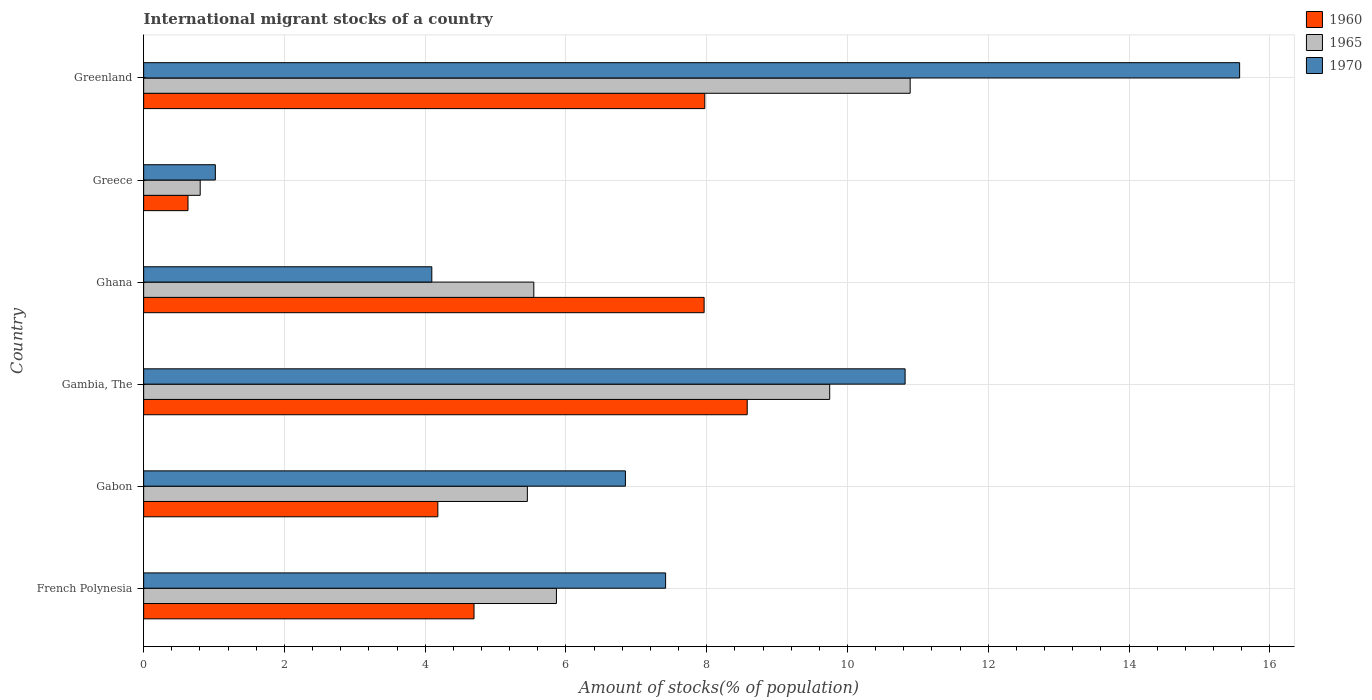How many groups of bars are there?
Make the answer very short. 6. Are the number of bars per tick equal to the number of legend labels?
Provide a succinct answer. Yes. Are the number of bars on each tick of the Y-axis equal?
Ensure brevity in your answer.  Yes. How many bars are there on the 2nd tick from the top?
Your answer should be compact. 3. How many bars are there on the 5th tick from the bottom?
Ensure brevity in your answer.  3. In how many cases, is the number of bars for a given country not equal to the number of legend labels?
Your answer should be very brief. 0. What is the amount of stocks in in 1965 in Greenland?
Offer a terse response. 10.89. Across all countries, what is the maximum amount of stocks in in 1960?
Keep it short and to the point. 8.58. Across all countries, what is the minimum amount of stocks in in 1965?
Your answer should be very brief. 0.8. In which country was the amount of stocks in in 1970 maximum?
Ensure brevity in your answer.  Greenland. In which country was the amount of stocks in in 1960 minimum?
Keep it short and to the point. Greece. What is the total amount of stocks in in 1970 in the graph?
Offer a terse response. 45.76. What is the difference between the amount of stocks in in 1960 in Gabon and that in Gambia, The?
Your response must be concise. -4.4. What is the difference between the amount of stocks in in 1970 in Ghana and the amount of stocks in in 1960 in Gabon?
Offer a very short reply. -0.09. What is the average amount of stocks in in 1960 per country?
Offer a very short reply. 5.67. What is the difference between the amount of stocks in in 1965 and amount of stocks in in 1960 in Greece?
Your answer should be compact. 0.17. In how many countries, is the amount of stocks in in 1960 greater than 2.8 %?
Your response must be concise. 5. What is the ratio of the amount of stocks in in 1965 in Gabon to that in Gambia, The?
Provide a short and direct response. 0.56. Is the amount of stocks in in 1960 in French Polynesia less than that in Ghana?
Offer a terse response. Yes. Is the difference between the amount of stocks in in 1965 in Gabon and Ghana greater than the difference between the amount of stocks in in 1960 in Gabon and Ghana?
Your response must be concise. Yes. What is the difference between the highest and the second highest amount of stocks in in 1970?
Your answer should be compact. 4.75. What is the difference between the highest and the lowest amount of stocks in in 1960?
Ensure brevity in your answer.  7.95. In how many countries, is the amount of stocks in in 1965 greater than the average amount of stocks in in 1965 taken over all countries?
Your answer should be very brief. 2. What does the 2nd bar from the top in French Polynesia represents?
Your answer should be compact. 1965. What does the 3rd bar from the bottom in Gambia, The represents?
Provide a short and direct response. 1970. Are all the bars in the graph horizontal?
Provide a succinct answer. Yes. Does the graph contain any zero values?
Your answer should be compact. No. Does the graph contain grids?
Offer a very short reply. Yes. How many legend labels are there?
Offer a terse response. 3. How are the legend labels stacked?
Your response must be concise. Vertical. What is the title of the graph?
Make the answer very short. International migrant stocks of a country. Does "1982" appear as one of the legend labels in the graph?
Your answer should be compact. No. What is the label or title of the X-axis?
Keep it short and to the point. Amount of stocks(% of population). What is the label or title of the Y-axis?
Make the answer very short. Country. What is the Amount of stocks(% of population) of 1960 in French Polynesia?
Offer a very short reply. 4.69. What is the Amount of stocks(% of population) in 1965 in French Polynesia?
Provide a succinct answer. 5.86. What is the Amount of stocks(% of population) in 1970 in French Polynesia?
Your answer should be very brief. 7.42. What is the Amount of stocks(% of population) of 1960 in Gabon?
Keep it short and to the point. 4.18. What is the Amount of stocks(% of population) in 1965 in Gabon?
Offer a very short reply. 5.45. What is the Amount of stocks(% of population) in 1970 in Gabon?
Keep it short and to the point. 6.84. What is the Amount of stocks(% of population) in 1960 in Gambia, The?
Your answer should be very brief. 8.58. What is the Amount of stocks(% of population) of 1965 in Gambia, The?
Provide a succinct answer. 9.75. What is the Amount of stocks(% of population) of 1970 in Gambia, The?
Offer a terse response. 10.82. What is the Amount of stocks(% of population) of 1960 in Ghana?
Provide a succinct answer. 7.96. What is the Amount of stocks(% of population) in 1965 in Ghana?
Keep it short and to the point. 5.54. What is the Amount of stocks(% of population) in 1970 in Ghana?
Give a very brief answer. 4.09. What is the Amount of stocks(% of population) of 1960 in Greece?
Provide a succinct answer. 0.63. What is the Amount of stocks(% of population) in 1965 in Greece?
Give a very brief answer. 0.8. What is the Amount of stocks(% of population) of 1970 in Greece?
Your response must be concise. 1.02. What is the Amount of stocks(% of population) of 1960 in Greenland?
Your answer should be very brief. 7.97. What is the Amount of stocks(% of population) in 1965 in Greenland?
Offer a terse response. 10.89. What is the Amount of stocks(% of population) in 1970 in Greenland?
Ensure brevity in your answer.  15.57. Across all countries, what is the maximum Amount of stocks(% of population) in 1960?
Give a very brief answer. 8.58. Across all countries, what is the maximum Amount of stocks(% of population) in 1965?
Make the answer very short. 10.89. Across all countries, what is the maximum Amount of stocks(% of population) in 1970?
Offer a very short reply. 15.57. Across all countries, what is the minimum Amount of stocks(% of population) in 1960?
Offer a terse response. 0.63. Across all countries, what is the minimum Amount of stocks(% of population) in 1965?
Make the answer very short. 0.8. Across all countries, what is the minimum Amount of stocks(% of population) of 1970?
Make the answer very short. 1.02. What is the total Amount of stocks(% of population) in 1960 in the graph?
Make the answer very short. 34.01. What is the total Amount of stocks(% of population) in 1965 in the graph?
Offer a terse response. 38.3. What is the total Amount of stocks(% of population) in 1970 in the graph?
Make the answer very short. 45.76. What is the difference between the Amount of stocks(% of population) in 1960 in French Polynesia and that in Gabon?
Provide a succinct answer. 0.51. What is the difference between the Amount of stocks(% of population) in 1965 in French Polynesia and that in Gabon?
Offer a very short reply. 0.41. What is the difference between the Amount of stocks(% of population) in 1970 in French Polynesia and that in Gabon?
Ensure brevity in your answer.  0.57. What is the difference between the Amount of stocks(% of population) in 1960 in French Polynesia and that in Gambia, The?
Ensure brevity in your answer.  -3.88. What is the difference between the Amount of stocks(% of population) of 1965 in French Polynesia and that in Gambia, The?
Provide a succinct answer. -3.88. What is the difference between the Amount of stocks(% of population) of 1970 in French Polynesia and that in Gambia, The?
Keep it short and to the point. -3.4. What is the difference between the Amount of stocks(% of population) in 1960 in French Polynesia and that in Ghana?
Your answer should be compact. -3.27. What is the difference between the Amount of stocks(% of population) of 1965 in French Polynesia and that in Ghana?
Offer a very short reply. 0.32. What is the difference between the Amount of stocks(% of population) in 1970 in French Polynesia and that in Ghana?
Give a very brief answer. 3.32. What is the difference between the Amount of stocks(% of population) in 1960 in French Polynesia and that in Greece?
Provide a short and direct response. 4.06. What is the difference between the Amount of stocks(% of population) in 1965 in French Polynesia and that in Greece?
Keep it short and to the point. 5.06. What is the difference between the Amount of stocks(% of population) of 1970 in French Polynesia and that in Greece?
Make the answer very short. 6.4. What is the difference between the Amount of stocks(% of population) in 1960 in French Polynesia and that in Greenland?
Your answer should be very brief. -3.28. What is the difference between the Amount of stocks(% of population) in 1965 in French Polynesia and that in Greenland?
Your answer should be compact. -5.03. What is the difference between the Amount of stocks(% of population) of 1970 in French Polynesia and that in Greenland?
Your response must be concise. -8.16. What is the difference between the Amount of stocks(% of population) in 1960 in Gabon and that in Gambia, The?
Ensure brevity in your answer.  -4.4. What is the difference between the Amount of stocks(% of population) in 1965 in Gabon and that in Gambia, The?
Your answer should be very brief. -4.3. What is the difference between the Amount of stocks(% of population) in 1970 in Gabon and that in Gambia, The?
Your answer should be compact. -3.97. What is the difference between the Amount of stocks(% of population) in 1960 in Gabon and that in Ghana?
Offer a very short reply. -3.78. What is the difference between the Amount of stocks(% of population) in 1965 in Gabon and that in Ghana?
Provide a short and direct response. -0.09. What is the difference between the Amount of stocks(% of population) in 1970 in Gabon and that in Ghana?
Your answer should be compact. 2.75. What is the difference between the Amount of stocks(% of population) in 1960 in Gabon and that in Greece?
Provide a succinct answer. 3.55. What is the difference between the Amount of stocks(% of population) of 1965 in Gabon and that in Greece?
Your answer should be compact. 4.65. What is the difference between the Amount of stocks(% of population) of 1970 in Gabon and that in Greece?
Provide a succinct answer. 5.83. What is the difference between the Amount of stocks(% of population) in 1960 in Gabon and that in Greenland?
Your answer should be compact. -3.79. What is the difference between the Amount of stocks(% of population) of 1965 in Gabon and that in Greenland?
Provide a succinct answer. -5.44. What is the difference between the Amount of stocks(% of population) of 1970 in Gabon and that in Greenland?
Keep it short and to the point. -8.73. What is the difference between the Amount of stocks(% of population) in 1960 in Gambia, The and that in Ghana?
Keep it short and to the point. 0.61. What is the difference between the Amount of stocks(% of population) of 1965 in Gambia, The and that in Ghana?
Your answer should be compact. 4.2. What is the difference between the Amount of stocks(% of population) in 1970 in Gambia, The and that in Ghana?
Offer a very short reply. 6.72. What is the difference between the Amount of stocks(% of population) of 1960 in Gambia, The and that in Greece?
Offer a very short reply. 7.95. What is the difference between the Amount of stocks(% of population) of 1965 in Gambia, The and that in Greece?
Your answer should be very brief. 8.94. What is the difference between the Amount of stocks(% of population) in 1970 in Gambia, The and that in Greece?
Ensure brevity in your answer.  9.8. What is the difference between the Amount of stocks(% of population) of 1960 in Gambia, The and that in Greenland?
Offer a terse response. 0.6. What is the difference between the Amount of stocks(% of population) in 1965 in Gambia, The and that in Greenland?
Make the answer very short. -1.14. What is the difference between the Amount of stocks(% of population) in 1970 in Gambia, The and that in Greenland?
Ensure brevity in your answer.  -4.75. What is the difference between the Amount of stocks(% of population) in 1960 in Ghana and that in Greece?
Give a very brief answer. 7.33. What is the difference between the Amount of stocks(% of population) of 1965 in Ghana and that in Greece?
Your response must be concise. 4.74. What is the difference between the Amount of stocks(% of population) in 1970 in Ghana and that in Greece?
Your answer should be compact. 3.08. What is the difference between the Amount of stocks(% of population) in 1960 in Ghana and that in Greenland?
Make the answer very short. -0.01. What is the difference between the Amount of stocks(% of population) of 1965 in Ghana and that in Greenland?
Offer a terse response. -5.35. What is the difference between the Amount of stocks(% of population) of 1970 in Ghana and that in Greenland?
Your answer should be very brief. -11.48. What is the difference between the Amount of stocks(% of population) of 1960 in Greece and that in Greenland?
Provide a short and direct response. -7.34. What is the difference between the Amount of stocks(% of population) in 1965 in Greece and that in Greenland?
Provide a short and direct response. -10.09. What is the difference between the Amount of stocks(% of population) in 1970 in Greece and that in Greenland?
Give a very brief answer. -14.55. What is the difference between the Amount of stocks(% of population) in 1960 in French Polynesia and the Amount of stocks(% of population) in 1965 in Gabon?
Provide a succinct answer. -0.76. What is the difference between the Amount of stocks(% of population) in 1960 in French Polynesia and the Amount of stocks(% of population) in 1970 in Gabon?
Give a very brief answer. -2.15. What is the difference between the Amount of stocks(% of population) of 1965 in French Polynesia and the Amount of stocks(% of population) of 1970 in Gabon?
Ensure brevity in your answer.  -0.98. What is the difference between the Amount of stocks(% of population) in 1960 in French Polynesia and the Amount of stocks(% of population) in 1965 in Gambia, The?
Ensure brevity in your answer.  -5.05. What is the difference between the Amount of stocks(% of population) of 1960 in French Polynesia and the Amount of stocks(% of population) of 1970 in Gambia, The?
Keep it short and to the point. -6.12. What is the difference between the Amount of stocks(% of population) of 1965 in French Polynesia and the Amount of stocks(% of population) of 1970 in Gambia, The?
Make the answer very short. -4.95. What is the difference between the Amount of stocks(% of population) in 1960 in French Polynesia and the Amount of stocks(% of population) in 1965 in Ghana?
Ensure brevity in your answer.  -0.85. What is the difference between the Amount of stocks(% of population) of 1960 in French Polynesia and the Amount of stocks(% of population) of 1970 in Ghana?
Make the answer very short. 0.6. What is the difference between the Amount of stocks(% of population) in 1965 in French Polynesia and the Amount of stocks(% of population) in 1970 in Ghana?
Your response must be concise. 1.77. What is the difference between the Amount of stocks(% of population) in 1960 in French Polynesia and the Amount of stocks(% of population) in 1965 in Greece?
Give a very brief answer. 3.89. What is the difference between the Amount of stocks(% of population) of 1960 in French Polynesia and the Amount of stocks(% of population) of 1970 in Greece?
Provide a succinct answer. 3.67. What is the difference between the Amount of stocks(% of population) of 1965 in French Polynesia and the Amount of stocks(% of population) of 1970 in Greece?
Make the answer very short. 4.85. What is the difference between the Amount of stocks(% of population) in 1960 in French Polynesia and the Amount of stocks(% of population) in 1965 in Greenland?
Keep it short and to the point. -6.2. What is the difference between the Amount of stocks(% of population) of 1960 in French Polynesia and the Amount of stocks(% of population) of 1970 in Greenland?
Offer a very short reply. -10.88. What is the difference between the Amount of stocks(% of population) of 1965 in French Polynesia and the Amount of stocks(% of population) of 1970 in Greenland?
Your response must be concise. -9.71. What is the difference between the Amount of stocks(% of population) in 1960 in Gabon and the Amount of stocks(% of population) in 1965 in Gambia, The?
Give a very brief answer. -5.57. What is the difference between the Amount of stocks(% of population) in 1960 in Gabon and the Amount of stocks(% of population) in 1970 in Gambia, The?
Ensure brevity in your answer.  -6.64. What is the difference between the Amount of stocks(% of population) of 1965 in Gabon and the Amount of stocks(% of population) of 1970 in Gambia, The?
Keep it short and to the point. -5.37. What is the difference between the Amount of stocks(% of population) in 1960 in Gabon and the Amount of stocks(% of population) in 1965 in Ghana?
Offer a very short reply. -1.36. What is the difference between the Amount of stocks(% of population) of 1960 in Gabon and the Amount of stocks(% of population) of 1970 in Ghana?
Ensure brevity in your answer.  0.09. What is the difference between the Amount of stocks(% of population) of 1965 in Gabon and the Amount of stocks(% of population) of 1970 in Ghana?
Ensure brevity in your answer.  1.36. What is the difference between the Amount of stocks(% of population) in 1960 in Gabon and the Amount of stocks(% of population) in 1965 in Greece?
Offer a terse response. 3.38. What is the difference between the Amount of stocks(% of population) of 1960 in Gabon and the Amount of stocks(% of population) of 1970 in Greece?
Make the answer very short. 3.16. What is the difference between the Amount of stocks(% of population) of 1965 in Gabon and the Amount of stocks(% of population) of 1970 in Greece?
Provide a succinct answer. 4.43. What is the difference between the Amount of stocks(% of population) of 1960 in Gabon and the Amount of stocks(% of population) of 1965 in Greenland?
Your answer should be very brief. -6.71. What is the difference between the Amount of stocks(% of population) in 1960 in Gabon and the Amount of stocks(% of population) in 1970 in Greenland?
Provide a short and direct response. -11.39. What is the difference between the Amount of stocks(% of population) of 1965 in Gabon and the Amount of stocks(% of population) of 1970 in Greenland?
Provide a short and direct response. -10.12. What is the difference between the Amount of stocks(% of population) of 1960 in Gambia, The and the Amount of stocks(% of population) of 1965 in Ghana?
Make the answer very short. 3.03. What is the difference between the Amount of stocks(% of population) of 1960 in Gambia, The and the Amount of stocks(% of population) of 1970 in Ghana?
Your answer should be compact. 4.48. What is the difference between the Amount of stocks(% of population) in 1965 in Gambia, The and the Amount of stocks(% of population) in 1970 in Ghana?
Offer a terse response. 5.65. What is the difference between the Amount of stocks(% of population) in 1960 in Gambia, The and the Amount of stocks(% of population) in 1965 in Greece?
Your answer should be compact. 7.77. What is the difference between the Amount of stocks(% of population) in 1960 in Gambia, The and the Amount of stocks(% of population) in 1970 in Greece?
Your answer should be compact. 7.56. What is the difference between the Amount of stocks(% of population) of 1965 in Gambia, The and the Amount of stocks(% of population) of 1970 in Greece?
Your response must be concise. 8.73. What is the difference between the Amount of stocks(% of population) in 1960 in Gambia, The and the Amount of stocks(% of population) in 1965 in Greenland?
Provide a short and direct response. -2.31. What is the difference between the Amount of stocks(% of population) in 1960 in Gambia, The and the Amount of stocks(% of population) in 1970 in Greenland?
Your answer should be very brief. -7. What is the difference between the Amount of stocks(% of population) in 1965 in Gambia, The and the Amount of stocks(% of population) in 1970 in Greenland?
Ensure brevity in your answer.  -5.82. What is the difference between the Amount of stocks(% of population) in 1960 in Ghana and the Amount of stocks(% of population) in 1965 in Greece?
Keep it short and to the point. 7.16. What is the difference between the Amount of stocks(% of population) of 1960 in Ghana and the Amount of stocks(% of population) of 1970 in Greece?
Provide a short and direct response. 6.94. What is the difference between the Amount of stocks(% of population) in 1965 in Ghana and the Amount of stocks(% of population) in 1970 in Greece?
Your response must be concise. 4.52. What is the difference between the Amount of stocks(% of population) in 1960 in Ghana and the Amount of stocks(% of population) in 1965 in Greenland?
Offer a very short reply. -2.93. What is the difference between the Amount of stocks(% of population) of 1960 in Ghana and the Amount of stocks(% of population) of 1970 in Greenland?
Your answer should be very brief. -7.61. What is the difference between the Amount of stocks(% of population) in 1965 in Ghana and the Amount of stocks(% of population) in 1970 in Greenland?
Make the answer very short. -10.03. What is the difference between the Amount of stocks(% of population) in 1960 in Greece and the Amount of stocks(% of population) in 1965 in Greenland?
Your answer should be compact. -10.26. What is the difference between the Amount of stocks(% of population) of 1960 in Greece and the Amount of stocks(% of population) of 1970 in Greenland?
Give a very brief answer. -14.94. What is the difference between the Amount of stocks(% of population) of 1965 in Greece and the Amount of stocks(% of population) of 1970 in Greenland?
Provide a short and direct response. -14.77. What is the average Amount of stocks(% of population) in 1960 per country?
Your response must be concise. 5.67. What is the average Amount of stocks(% of population) of 1965 per country?
Provide a succinct answer. 6.38. What is the average Amount of stocks(% of population) of 1970 per country?
Ensure brevity in your answer.  7.63. What is the difference between the Amount of stocks(% of population) in 1960 and Amount of stocks(% of population) in 1965 in French Polynesia?
Offer a very short reply. -1.17. What is the difference between the Amount of stocks(% of population) of 1960 and Amount of stocks(% of population) of 1970 in French Polynesia?
Your answer should be compact. -2.72. What is the difference between the Amount of stocks(% of population) in 1965 and Amount of stocks(% of population) in 1970 in French Polynesia?
Make the answer very short. -1.55. What is the difference between the Amount of stocks(% of population) in 1960 and Amount of stocks(% of population) in 1965 in Gabon?
Make the answer very short. -1.27. What is the difference between the Amount of stocks(% of population) of 1960 and Amount of stocks(% of population) of 1970 in Gabon?
Ensure brevity in your answer.  -2.66. What is the difference between the Amount of stocks(% of population) of 1965 and Amount of stocks(% of population) of 1970 in Gabon?
Provide a short and direct response. -1.39. What is the difference between the Amount of stocks(% of population) in 1960 and Amount of stocks(% of population) in 1965 in Gambia, The?
Your response must be concise. -1.17. What is the difference between the Amount of stocks(% of population) in 1960 and Amount of stocks(% of population) in 1970 in Gambia, The?
Your response must be concise. -2.24. What is the difference between the Amount of stocks(% of population) of 1965 and Amount of stocks(% of population) of 1970 in Gambia, The?
Provide a short and direct response. -1.07. What is the difference between the Amount of stocks(% of population) of 1960 and Amount of stocks(% of population) of 1965 in Ghana?
Make the answer very short. 2.42. What is the difference between the Amount of stocks(% of population) in 1960 and Amount of stocks(% of population) in 1970 in Ghana?
Keep it short and to the point. 3.87. What is the difference between the Amount of stocks(% of population) in 1965 and Amount of stocks(% of population) in 1970 in Ghana?
Keep it short and to the point. 1.45. What is the difference between the Amount of stocks(% of population) in 1960 and Amount of stocks(% of population) in 1965 in Greece?
Give a very brief answer. -0.17. What is the difference between the Amount of stocks(% of population) of 1960 and Amount of stocks(% of population) of 1970 in Greece?
Offer a terse response. -0.39. What is the difference between the Amount of stocks(% of population) in 1965 and Amount of stocks(% of population) in 1970 in Greece?
Your answer should be compact. -0.22. What is the difference between the Amount of stocks(% of population) in 1960 and Amount of stocks(% of population) in 1965 in Greenland?
Ensure brevity in your answer.  -2.92. What is the difference between the Amount of stocks(% of population) in 1960 and Amount of stocks(% of population) in 1970 in Greenland?
Offer a terse response. -7.6. What is the difference between the Amount of stocks(% of population) of 1965 and Amount of stocks(% of population) of 1970 in Greenland?
Your response must be concise. -4.68. What is the ratio of the Amount of stocks(% of population) in 1960 in French Polynesia to that in Gabon?
Provide a succinct answer. 1.12. What is the ratio of the Amount of stocks(% of population) in 1965 in French Polynesia to that in Gabon?
Your response must be concise. 1.08. What is the ratio of the Amount of stocks(% of population) in 1970 in French Polynesia to that in Gabon?
Give a very brief answer. 1.08. What is the ratio of the Amount of stocks(% of population) in 1960 in French Polynesia to that in Gambia, The?
Offer a very short reply. 0.55. What is the ratio of the Amount of stocks(% of population) in 1965 in French Polynesia to that in Gambia, The?
Provide a short and direct response. 0.6. What is the ratio of the Amount of stocks(% of population) of 1970 in French Polynesia to that in Gambia, The?
Ensure brevity in your answer.  0.69. What is the ratio of the Amount of stocks(% of population) of 1960 in French Polynesia to that in Ghana?
Offer a very short reply. 0.59. What is the ratio of the Amount of stocks(% of population) in 1965 in French Polynesia to that in Ghana?
Offer a very short reply. 1.06. What is the ratio of the Amount of stocks(% of population) of 1970 in French Polynesia to that in Ghana?
Your response must be concise. 1.81. What is the ratio of the Amount of stocks(% of population) of 1960 in French Polynesia to that in Greece?
Give a very brief answer. 7.45. What is the ratio of the Amount of stocks(% of population) in 1965 in French Polynesia to that in Greece?
Keep it short and to the point. 7.3. What is the ratio of the Amount of stocks(% of population) in 1970 in French Polynesia to that in Greece?
Provide a short and direct response. 7.28. What is the ratio of the Amount of stocks(% of population) in 1960 in French Polynesia to that in Greenland?
Your response must be concise. 0.59. What is the ratio of the Amount of stocks(% of population) in 1965 in French Polynesia to that in Greenland?
Ensure brevity in your answer.  0.54. What is the ratio of the Amount of stocks(% of population) in 1970 in French Polynesia to that in Greenland?
Offer a very short reply. 0.48. What is the ratio of the Amount of stocks(% of population) of 1960 in Gabon to that in Gambia, The?
Provide a short and direct response. 0.49. What is the ratio of the Amount of stocks(% of population) in 1965 in Gabon to that in Gambia, The?
Keep it short and to the point. 0.56. What is the ratio of the Amount of stocks(% of population) in 1970 in Gabon to that in Gambia, The?
Keep it short and to the point. 0.63. What is the ratio of the Amount of stocks(% of population) of 1960 in Gabon to that in Ghana?
Make the answer very short. 0.52. What is the ratio of the Amount of stocks(% of population) of 1965 in Gabon to that in Ghana?
Keep it short and to the point. 0.98. What is the ratio of the Amount of stocks(% of population) of 1970 in Gabon to that in Ghana?
Offer a very short reply. 1.67. What is the ratio of the Amount of stocks(% of population) of 1960 in Gabon to that in Greece?
Keep it short and to the point. 6.63. What is the ratio of the Amount of stocks(% of population) in 1965 in Gabon to that in Greece?
Provide a short and direct response. 6.78. What is the ratio of the Amount of stocks(% of population) in 1970 in Gabon to that in Greece?
Offer a very short reply. 6.72. What is the ratio of the Amount of stocks(% of population) of 1960 in Gabon to that in Greenland?
Your response must be concise. 0.52. What is the ratio of the Amount of stocks(% of population) in 1965 in Gabon to that in Greenland?
Offer a terse response. 0.5. What is the ratio of the Amount of stocks(% of population) in 1970 in Gabon to that in Greenland?
Make the answer very short. 0.44. What is the ratio of the Amount of stocks(% of population) of 1960 in Gambia, The to that in Ghana?
Ensure brevity in your answer.  1.08. What is the ratio of the Amount of stocks(% of population) of 1965 in Gambia, The to that in Ghana?
Ensure brevity in your answer.  1.76. What is the ratio of the Amount of stocks(% of population) of 1970 in Gambia, The to that in Ghana?
Provide a short and direct response. 2.64. What is the ratio of the Amount of stocks(% of population) in 1960 in Gambia, The to that in Greece?
Offer a very short reply. 13.61. What is the ratio of the Amount of stocks(% of population) of 1965 in Gambia, The to that in Greece?
Ensure brevity in your answer.  12.13. What is the ratio of the Amount of stocks(% of population) in 1970 in Gambia, The to that in Greece?
Your answer should be very brief. 10.62. What is the ratio of the Amount of stocks(% of population) in 1960 in Gambia, The to that in Greenland?
Keep it short and to the point. 1.08. What is the ratio of the Amount of stocks(% of population) in 1965 in Gambia, The to that in Greenland?
Your answer should be compact. 0.9. What is the ratio of the Amount of stocks(% of population) of 1970 in Gambia, The to that in Greenland?
Make the answer very short. 0.69. What is the ratio of the Amount of stocks(% of population) in 1960 in Ghana to that in Greece?
Provide a short and direct response. 12.64. What is the ratio of the Amount of stocks(% of population) in 1965 in Ghana to that in Greece?
Provide a succinct answer. 6.9. What is the ratio of the Amount of stocks(% of population) in 1970 in Ghana to that in Greece?
Your response must be concise. 4.02. What is the ratio of the Amount of stocks(% of population) in 1965 in Ghana to that in Greenland?
Provide a short and direct response. 0.51. What is the ratio of the Amount of stocks(% of population) of 1970 in Ghana to that in Greenland?
Your answer should be very brief. 0.26. What is the ratio of the Amount of stocks(% of population) of 1960 in Greece to that in Greenland?
Offer a terse response. 0.08. What is the ratio of the Amount of stocks(% of population) in 1965 in Greece to that in Greenland?
Keep it short and to the point. 0.07. What is the ratio of the Amount of stocks(% of population) of 1970 in Greece to that in Greenland?
Offer a very short reply. 0.07. What is the difference between the highest and the second highest Amount of stocks(% of population) in 1960?
Your answer should be compact. 0.6. What is the difference between the highest and the second highest Amount of stocks(% of population) in 1965?
Your answer should be compact. 1.14. What is the difference between the highest and the second highest Amount of stocks(% of population) of 1970?
Keep it short and to the point. 4.75. What is the difference between the highest and the lowest Amount of stocks(% of population) in 1960?
Keep it short and to the point. 7.95. What is the difference between the highest and the lowest Amount of stocks(% of population) in 1965?
Offer a very short reply. 10.09. What is the difference between the highest and the lowest Amount of stocks(% of population) of 1970?
Your answer should be compact. 14.55. 